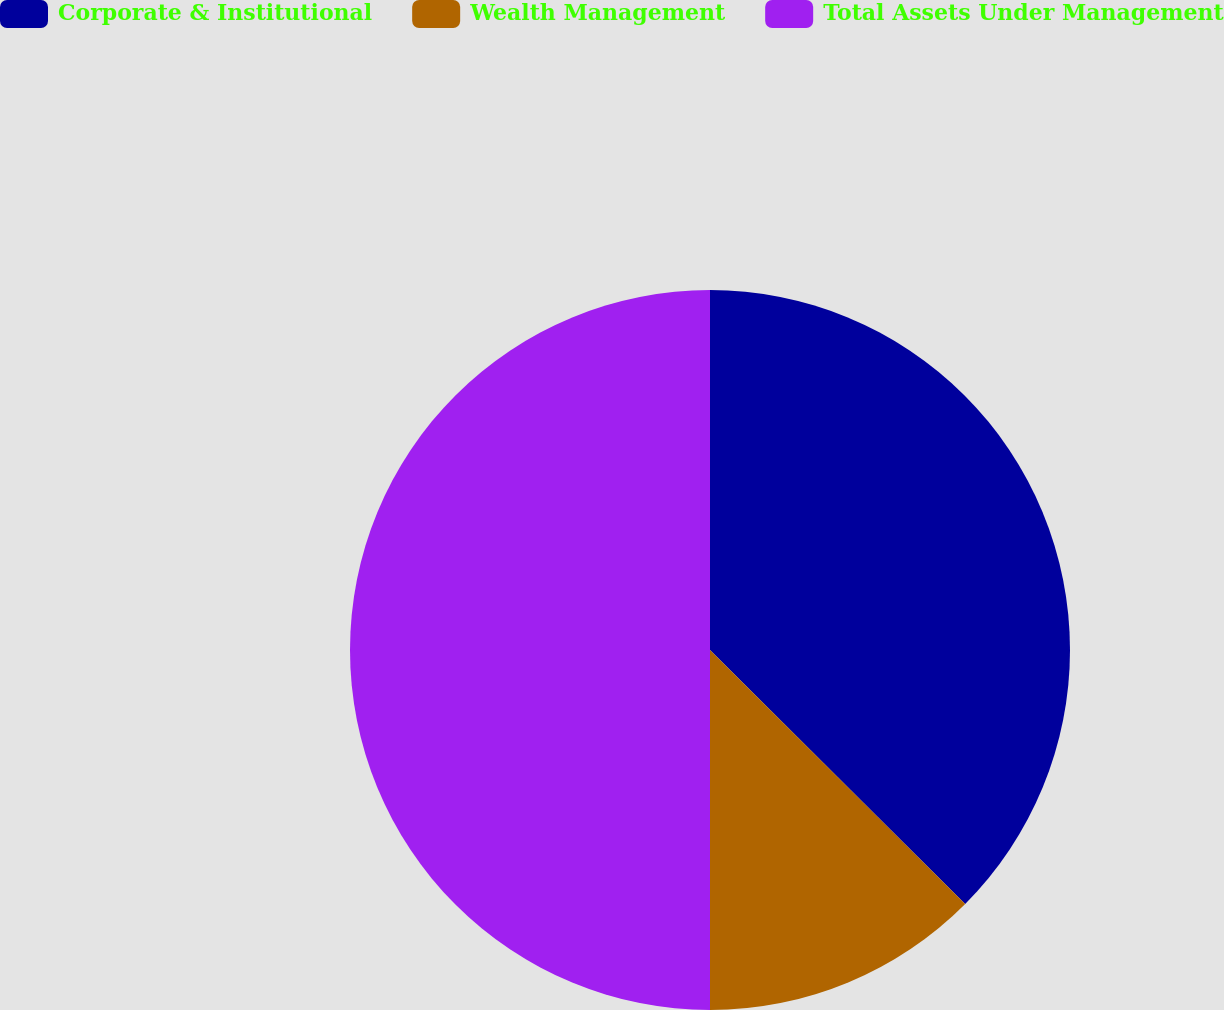Convert chart to OTSL. <chart><loc_0><loc_0><loc_500><loc_500><pie_chart><fcel>Corporate & Institutional<fcel>Wealth Management<fcel>Total Assets Under Management<nl><fcel>37.46%<fcel>12.54%<fcel>50.0%<nl></chart> 